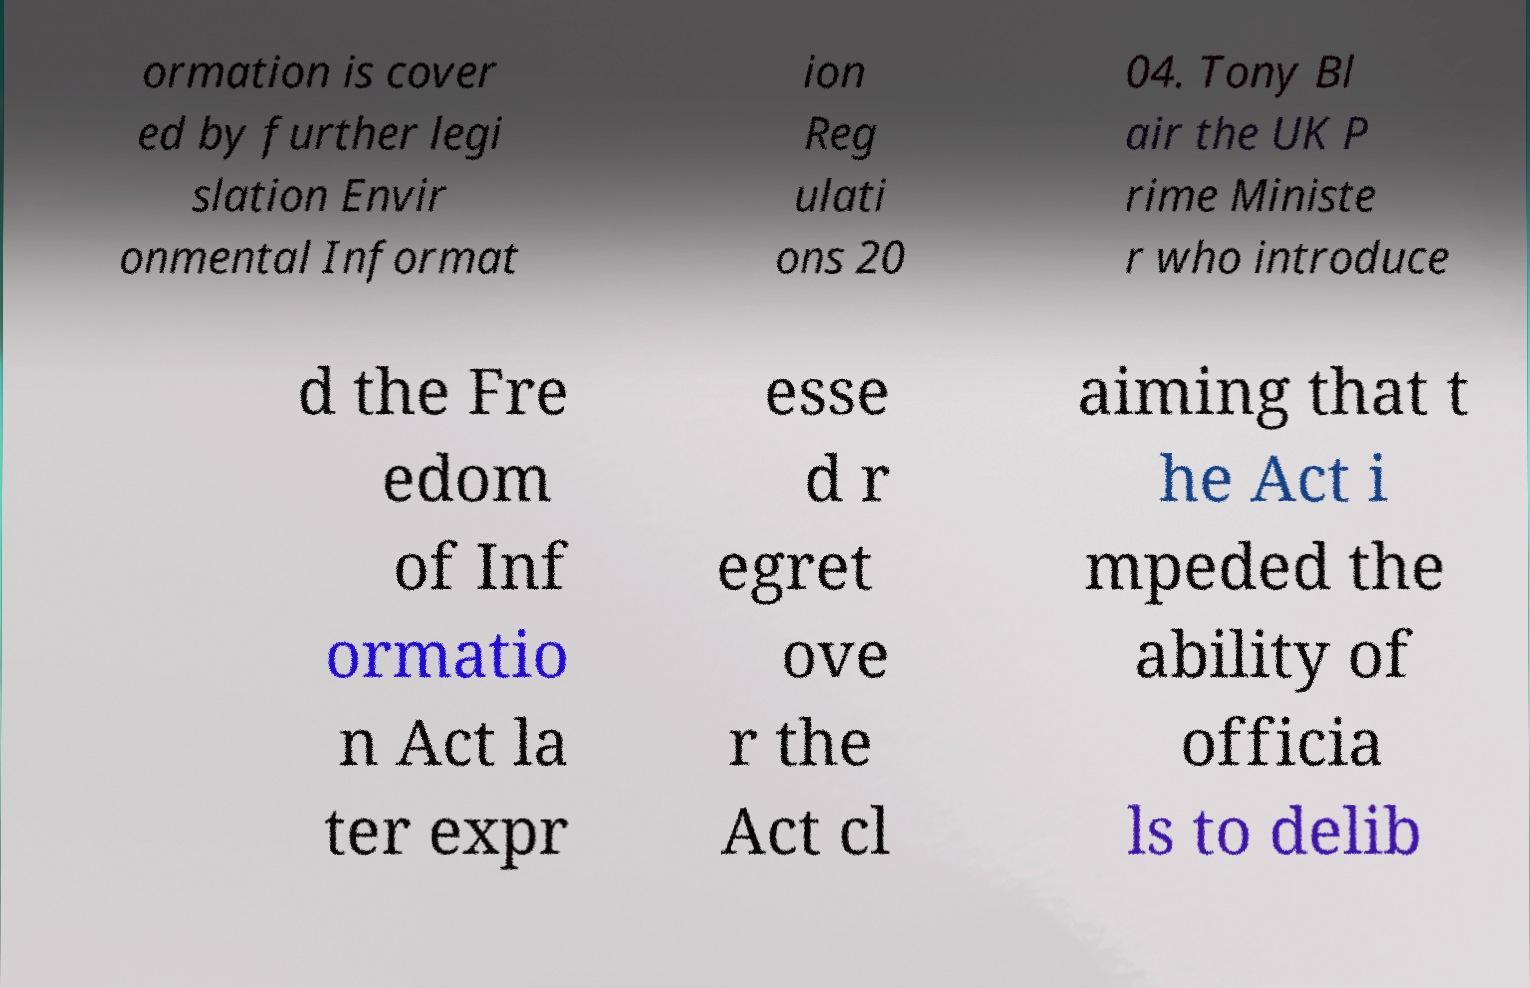There's text embedded in this image that I need extracted. Can you transcribe it verbatim? ormation is cover ed by further legi slation Envir onmental Informat ion Reg ulati ons 20 04. Tony Bl air the UK P rime Ministe r who introduce d the Fre edom of Inf ormatio n Act la ter expr esse d r egret ove r the Act cl aiming that t he Act i mpeded the ability of officia ls to delib 